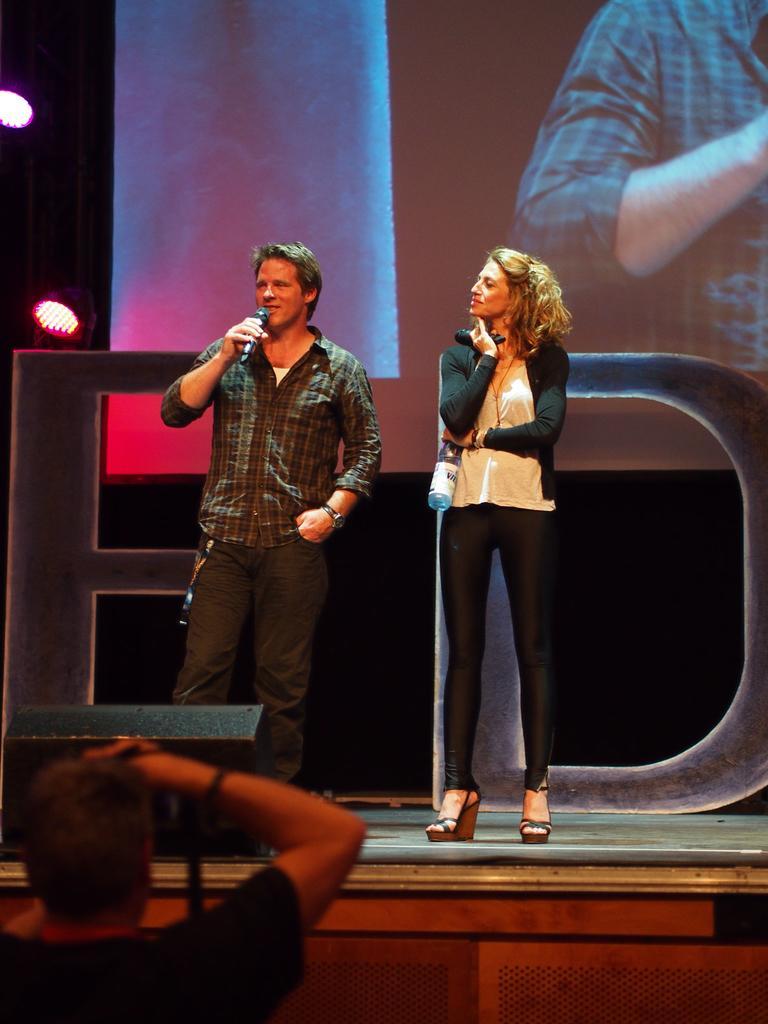In one or two sentences, can you explain what this image depicts? In this image, there are two persons standing. One is holding a mike and talking and one person is holding a bottle in her hand. At the bottom a person is there who is half visible. At the top a screen is there. This image is taken inside a stage during night time. 